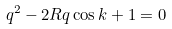Convert formula to latex. <formula><loc_0><loc_0><loc_500><loc_500>q ^ { 2 } - 2 R q \cos k + 1 = 0</formula> 